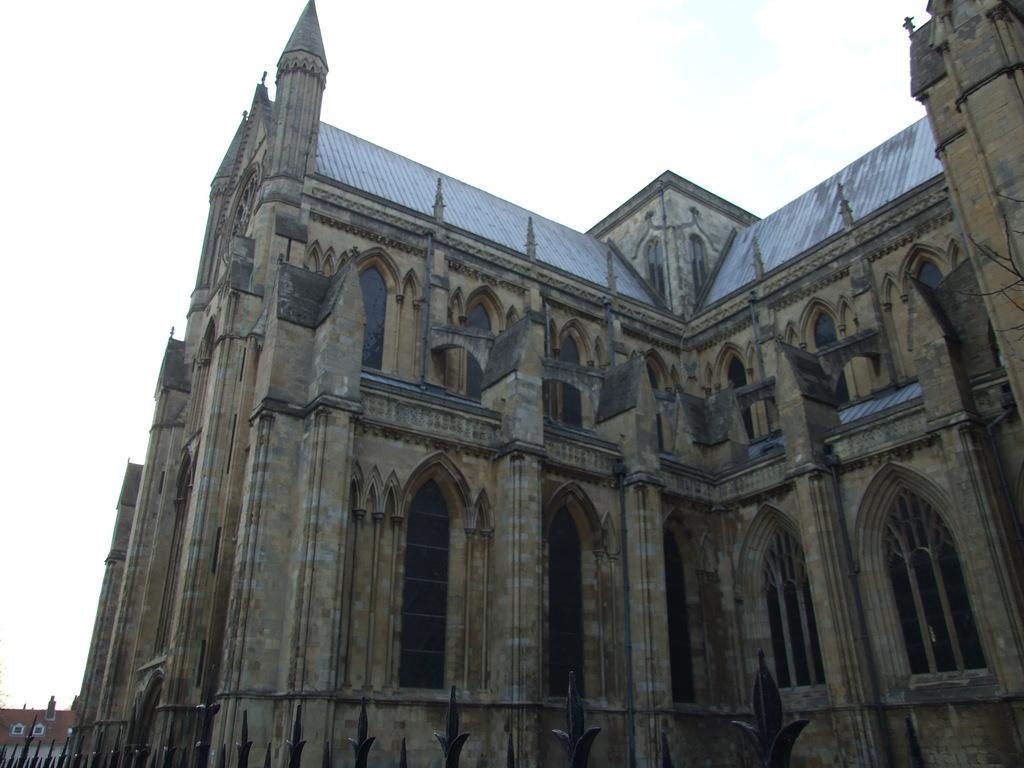Describe this image in one or two sentences. In this picture we can see an architecture. At the top there is a sky. 